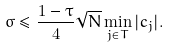Convert formula to latex. <formula><loc_0><loc_0><loc_500><loc_500>\sigma \leq \frac { 1 - \tau } { 4 } \sqrt { N } \min _ { j \in T } | c _ { j } | .</formula> 